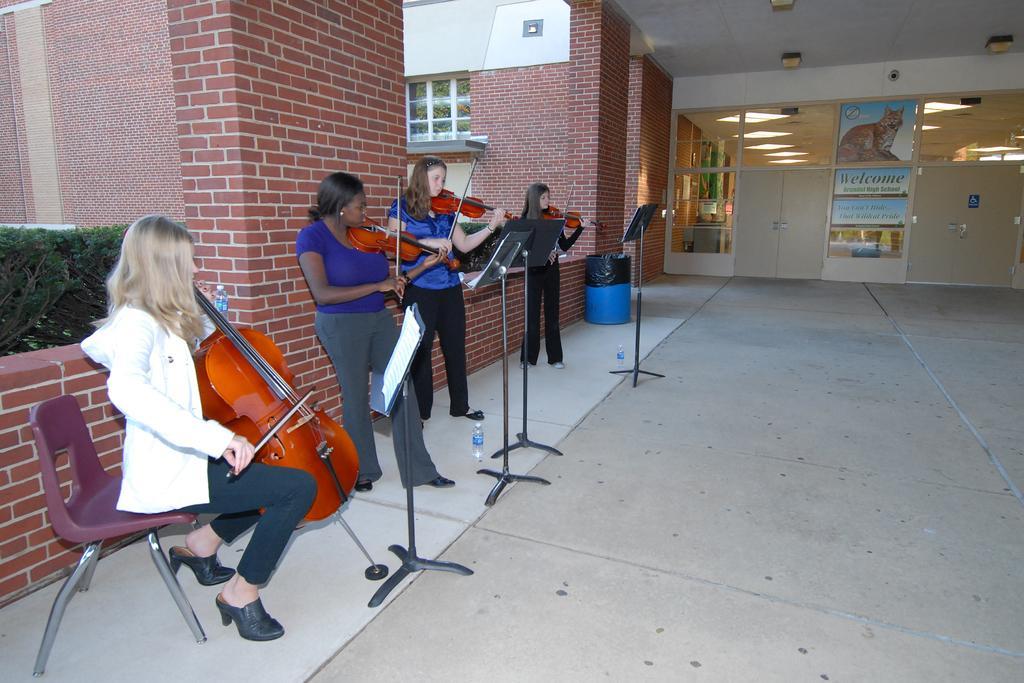Can you describe this image briefly? there are four women,in which one woman is sitting on the chair and another three women are standing and playing violin with a stand in front of them,there are standing under a building. 